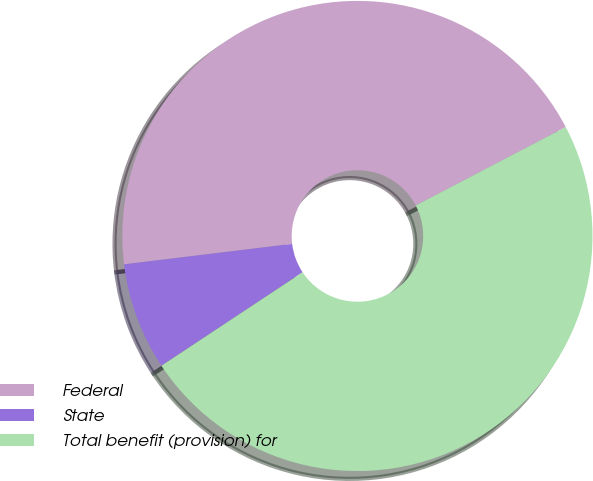<chart> <loc_0><loc_0><loc_500><loc_500><pie_chart><fcel>Federal<fcel>State<fcel>Total benefit (provision) for<nl><fcel>44.26%<fcel>7.38%<fcel>48.36%<nl></chart> 